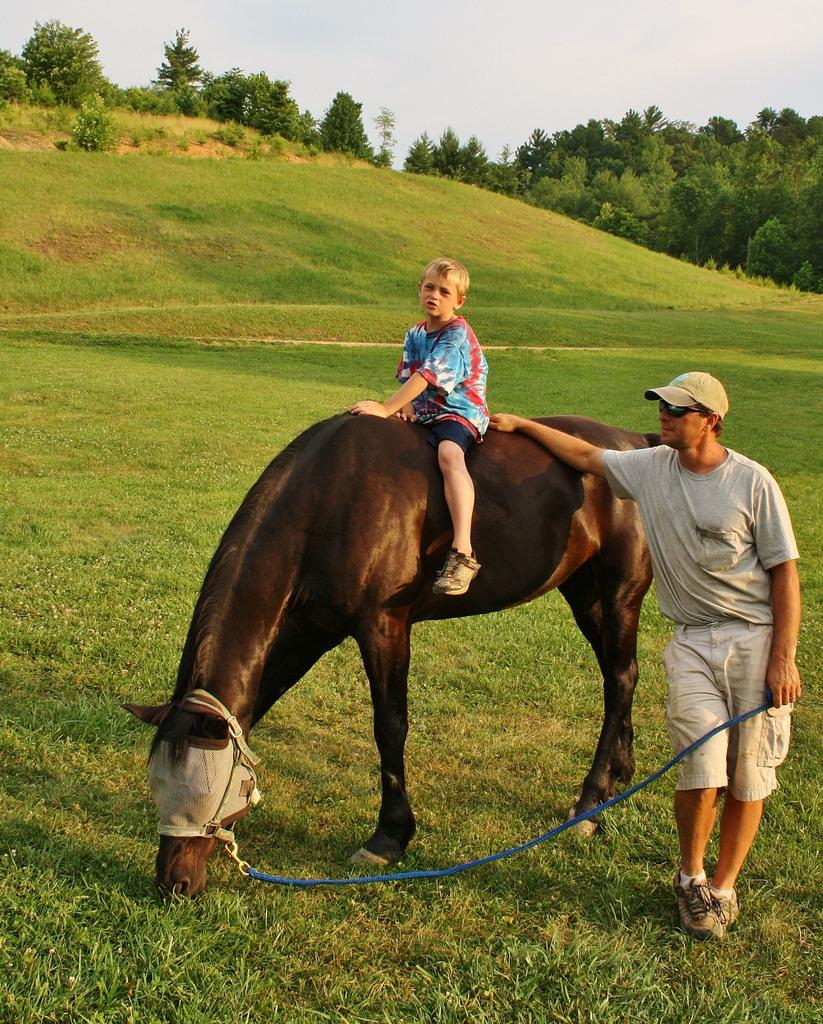What is the person in the image doing? The person is standing in the image and holding a rope. What is the kid in the image doing? The kid is sitting on a horse in the image. What type of vegetation is visible in the image? There is grass visible in the image. What else can be seen in the background of the image? There are trees and the sky visible in the image. What is the person wearing on their head? The person is wearing a cap. What is the person wearing on their face? The person is wearing glasses. What type of yam is being used as a prop in the image? There is no yam present in the image. Can you describe the person's attempt to ride the horse in the image? The person is not attempting to ride the horse in the image; they are standing and holding a rope. 